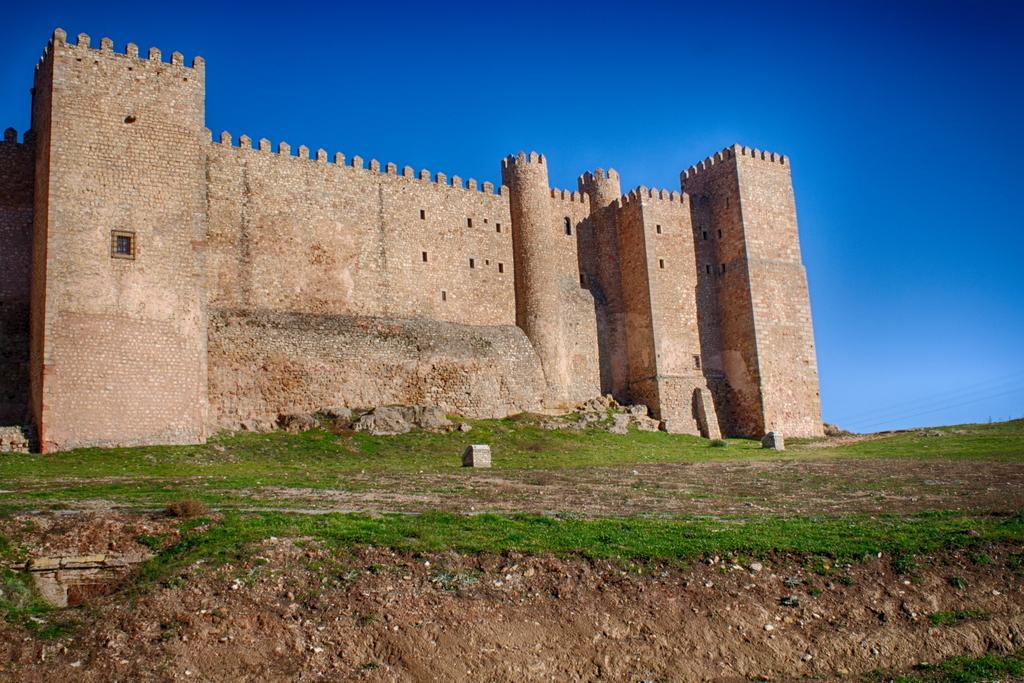What type of structure is in the image? There is a fort in the image. What type of terrain is at the bottom of the image? There is grass at the bottom of the image. What part of the natural environment is visible in the image? The sky is visible at the top of the image. Where is the chicken sitting in the image? There is no chicken present in the image. What advice does the mom give in the image? There is no mom or conversation depicted in the image. 